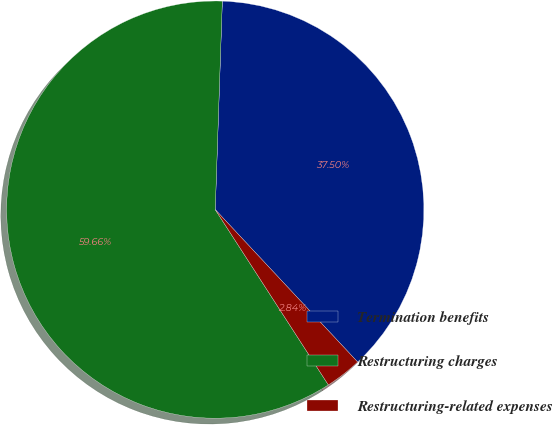<chart> <loc_0><loc_0><loc_500><loc_500><pie_chart><fcel>Termination benefits<fcel>Restructuring charges<fcel>Restructuring-related expenses<nl><fcel>37.5%<fcel>59.66%<fcel>2.84%<nl></chart> 